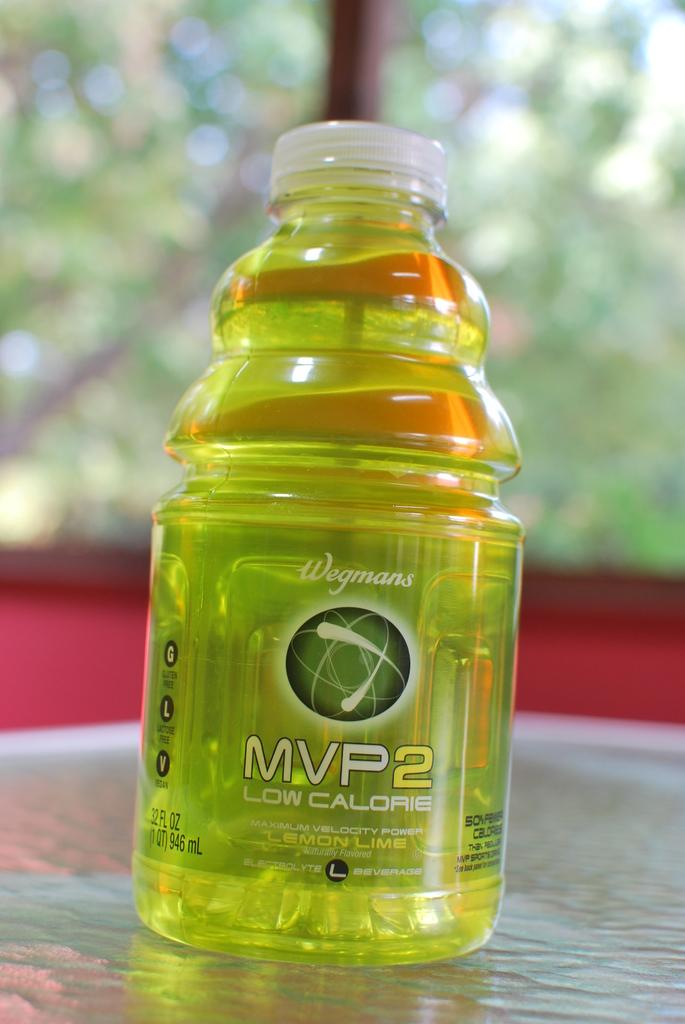What is the main object in the image? There is a bottle in the image. What is written on the bottle? The bottle has the name "MVP2 low calorie" on it. Where is the bottle located? The bottle is on a table. What can be seen in the background of the image? There are trees in the background of the image. What type of soda does the grandfather prefer in the image? There is no grandfather or soda mentioned in the image; it only features a bottle with the name "MVP2 low calorie" on it. Can you see a rod in the image? There is no rod present in the image. 